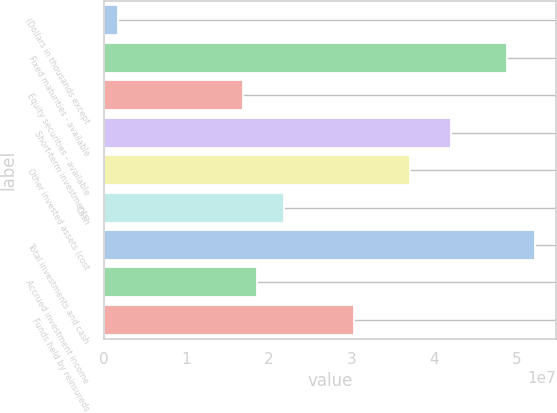<chart> <loc_0><loc_0><loc_500><loc_500><bar_chart><fcel>(Dollars in thousands except<fcel>Fixed maturities - available<fcel>Equity securities - available<fcel>Short-term investments<fcel>Other invested assets (cost<fcel>Cash<fcel>Total investments and cash<fcel>Accrued investment income<fcel>Funds held by reinsureds<nl><fcel>1.68525e+06<fcel>4.88539e+07<fcel>1.68466e+07<fcel>4.21155e+07<fcel>3.70617e+07<fcel>2.19004e+07<fcel>5.22231e+07<fcel>1.85312e+07<fcel>3.03233e+07<nl></chart> 